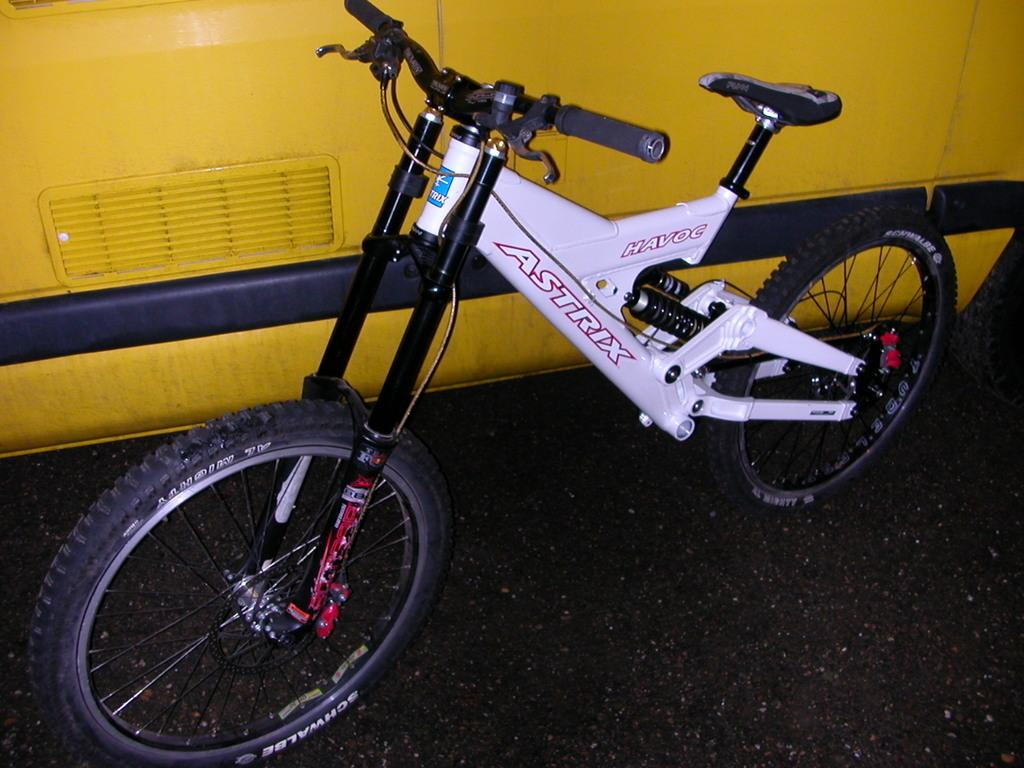What is the color of the ground in the image? The ground in the image is black in color. What mode of transportation can be seen in the image? There is a bicycle in the image. What is the color scheme of the bicycle? The bicycle is black and white in color. What other type of vehicle is present in the image? There is a vehicle in the image. What colors are used for the vehicle? The vehicle is yellow and black in color. Where is the goose located in the image? There is no goose present in the image. What unit of measurement is used to determine the size of the bicycle in the image? The facts provided do not mention any unit of measurement for the bicycle's size. 